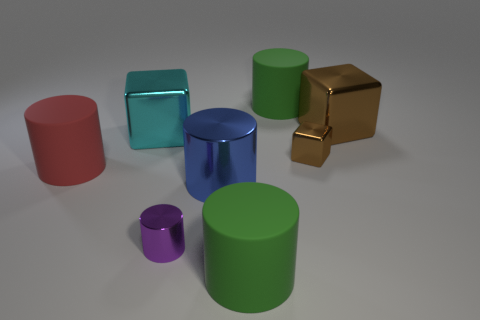What is the shape of the small brown thing that is made of the same material as the big blue object? The small brown item shares its cube-shape with the larger blue object, showcasing the angular and symmetrical properties characteristic of this six-sided three-dimensional figure. 